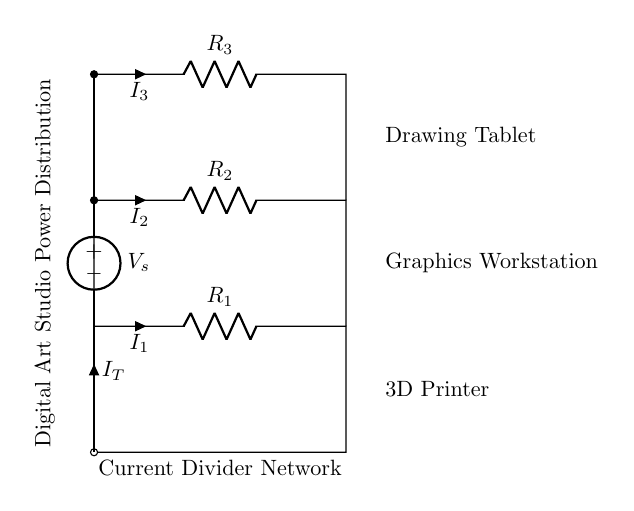What is the total current entering the circuit? The total current entering the circuit is denoted as I_T, which represents the sum of the currents I_1, I_2, and I_3 flowing through the resistors R_1, R_2, and R_3.
Answer: I_T How many resistors are in the current divider network? The current divider network contains three resistors, which are R_1, R_2, and R_3.
Answer: Three Which component has the highest voltage drop? In a current divider, the voltage drop across each resistor depends on its resistance value and the current flowing through it. Without specific resistance values, we can't determine which has the highest drop, but typically the one with the highest resistance has the highest drop.
Answer: R_3 What is the purpose of the current divider in this setup? The purpose of the current divider in this setup is to split the total current I_T into various branch currents (I_1, I_2, I_3) that can be supplied to different devices like a 3D printer, graphics workstation, and drawing tablet.
Answer: To manage power distribution If R_2 is halved, what happens to I_2? If R_2 is halved, the current I_2 will increase because the current through a resistor is inversely proportional to its resistance; hence a decrease in resistance increases the current flowing through that branch.
Answer: I_2 increases Which device represents R_1 in the circuit? R_1 represents the current drawn by the 3D printer, as it is connected to the lowest part of the circuit diagram.
Answer: 3D Printer What is the significance of the voltage source in the circuit? The voltage source provides the necessary potential difference to drive the current through the resistors in the circuit, which is essential for the operation of the connected devices.
Answer: It powers the circuit 